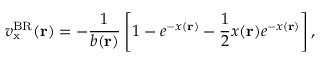<formula> <loc_0><loc_0><loc_500><loc_500>v _ { x } ^ { B R } ( r ) = - \frac { 1 } { b ( r ) } \left [ 1 - e ^ { - x ( r ) } - \frac { 1 } { 2 } x ( r ) e ^ { - x ( r ) } \right ] ,</formula> 